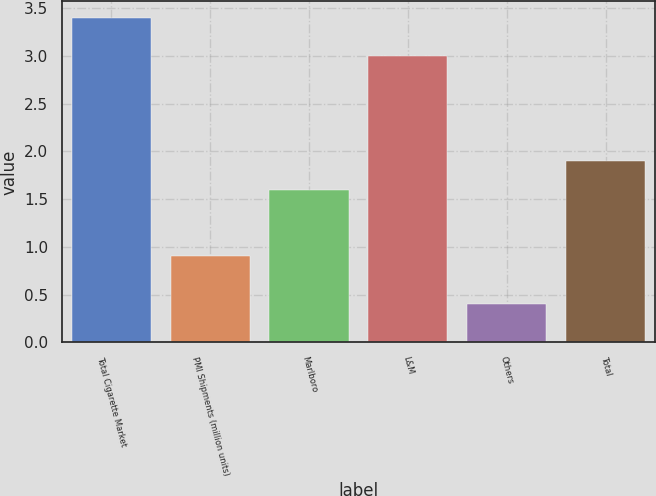Convert chart to OTSL. <chart><loc_0><loc_0><loc_500><loc_500><bar_chart><fcel>Total Cigarette Market<fcel>PMI Shipments (million units)<fcel>Marlboro<fcel>L&M<fcel>Others<fcel>Total<nl><fcel>3.4<fcel>0.9<fcel>1.6<fcel>3<fcel>0.4<fcel>1.9<nl></chart> 